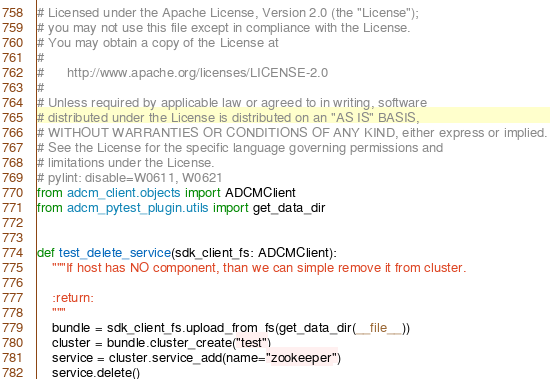Convert code to text. <code><loc_0><loc_0><loc_500><loc_500><_Python_># Licensed under the Apache License, Version 2.0 (the "License");
# you may not use this file except in compliance with the License.
# You may obtain a copy of the License at
#
#      http://www.apache.org/licenses/LICENSE-2.0
#
# Unless required by applicable law or agreed to in writing, software
# distributed under the License is distributed on an "AS IS" BASIS,
# WITHOUT WARRANTIES OR CONDITIONS OF ANY KIND, either express or implied.
# See the License for the specific language governing permissions and
# limitations under the License.
# pylint: disable=W0611, W0621
from adcm_client.objects import ADCMClient
from adcm_pytest_plugin.utils import get_data_dir


def test_delete_service(sdk_client_fs: ADCMClient):
    """If host has NO component, than we can simple remove it from cluster.

    :return:
    """
    bundle = sdk_client_fs.upload_from_fs(get_data_dir(__file__))
    cluster = bundle.cluster_create("test")
    service = cluster.service_add(name="zookeeper")
    service.delete()
</code> 